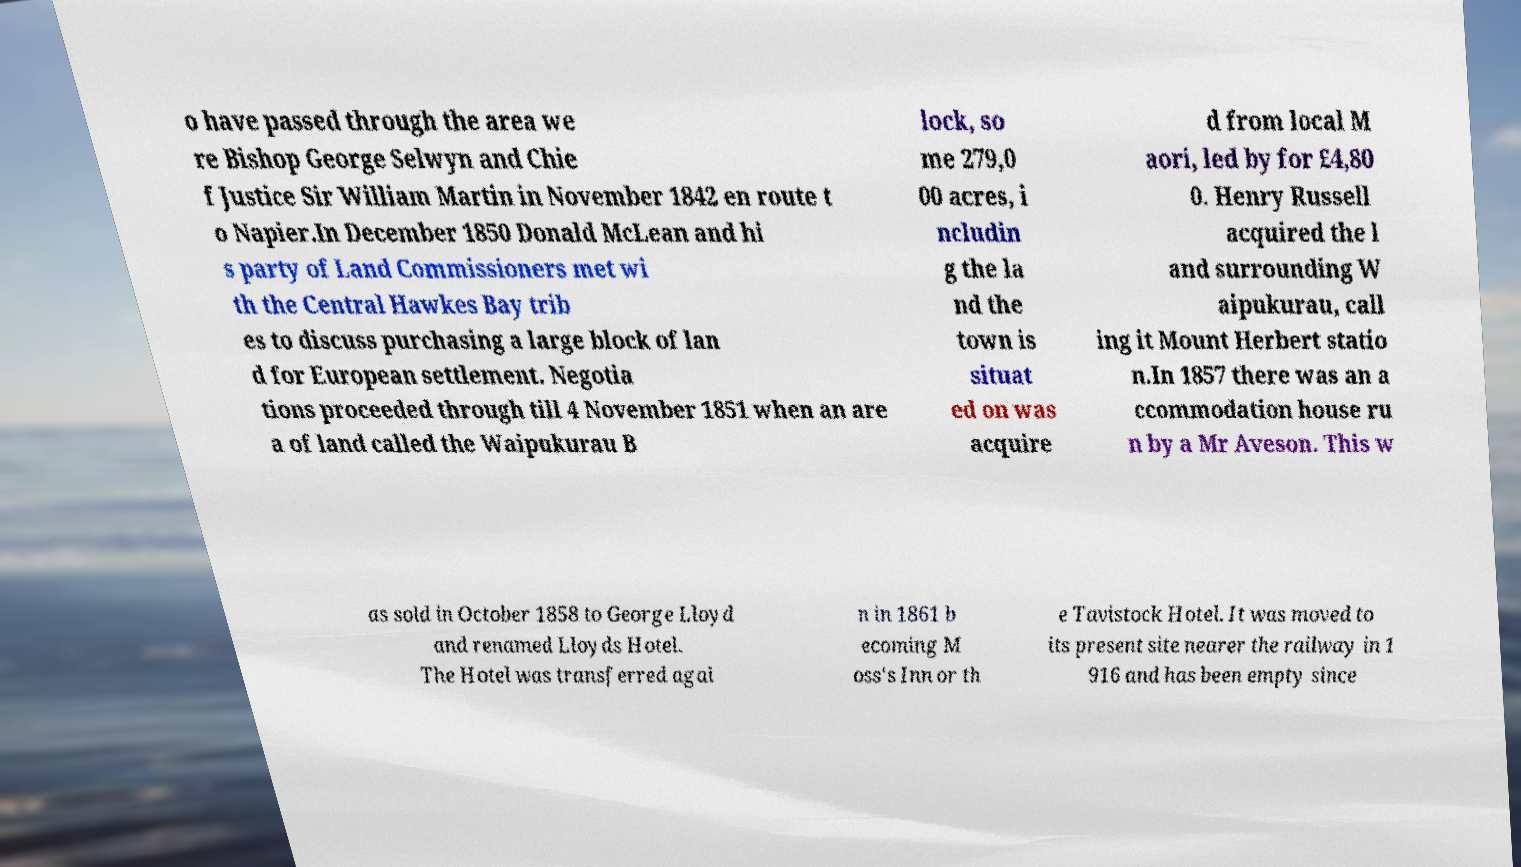For documentation purposes, I need the text within this image transcribed. Could you provide that? o have passed through the area we re Bishop George Selwyn and Chie f Justice Sir William Martin in November 1842 en route t o Napier.In December 1850 Donald McLean and hi s party of Land Commissioners met wi th the Central Hawkes Bay trib es to discuss purchasing a large block of lan d for European settlement. Negotia tions proceeded through till 4 November 1851 when an are a of land called the Waipukurau B lock, so me 279,0 00 acres, i ncludin g the la nd the town is situat ed on was acquire d from local M aori, led by for £4,80 0. Henry Russell acquired the l and surrounding W aipukurau, call ing it Mount Herbert statio n.In 1857 there was an a ccommodation house ru n by a Mr Aveson. This w as sold in October 1858 to George Lloyd and renamed Lloyds Hotel. The Hotel was transferred agai n in 1861 b ecoming M oss's Inn or th e Tavistock Hotel. It was moved to its present site nearer the railway in 1 916 and has been empty since 